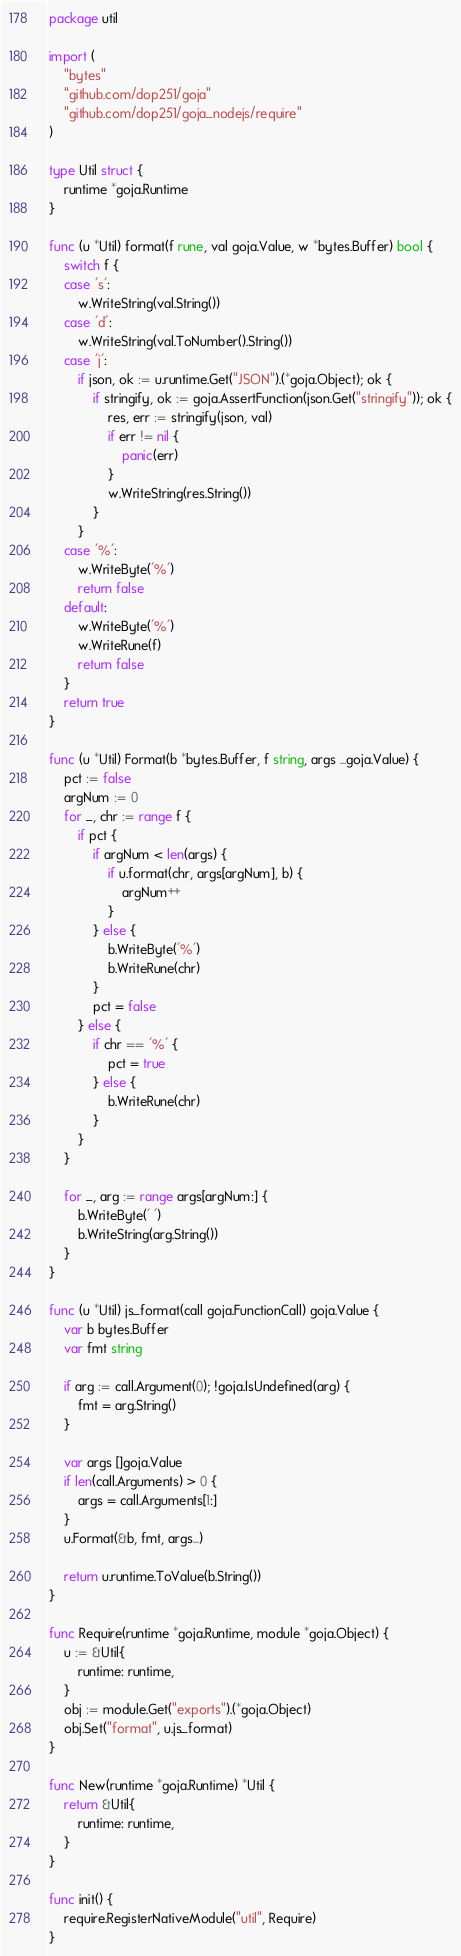<code> <loc_0><loc_0><loc_500><loc_500><_Go_>package util

import (
	"bytes"
	"github.com/dop251/goja"
	"github.com/dop251/goja_nodejs/require"
)

type Util struct {
	runtime *goja.Runtime
}

func (u *Util) format(f rune, val goja.Value, w *bytes.Buffer) bool {
	switch f {
	case 's':
		w.WriteString(val.String())
	case 'd':
		w.WriteString(val.ToNumber().String())
	case 'j':
		if json, ok := u.runtime.Get("JSON").(*goja.Object); ok {
			if stringify, ok := goja.AssertFunction(json.Get("stringify")); ok {
				res, err := stringify(json, val)
				if err != nil {
					panic(err)
				}
				w.WriteString(res.String())
			}
		}
	case '%':
		w.WriteByte('%')
		return false
	default:
		w.WriteByte('%')
		w.WriteRune(f)
		return false
	}
	return true
}

func (u *Util) Format(b *bytes.Buffer, f string, args ...goja.Value) {
	pct := false
	argNum := 0
	for _, chr := range f {
		if pct {
			if argNum < len(args) {
				if u.format(chr, args[argNum], b) {
					argNum++
				}
			} else {
				b.WriteByte('%')
				b.WriteRune(chr)
			}
			pct = false
		} else {
			if chr == '%' {
				pct = true
			} else {
				b.WriteRune(chr)
			}
		}
	}

	for _, arg := range args[argNum:] {
		b.WriteByte(' ')
		b.WriteString(arg.String())
	}
}

func (u *Util) js_format(call goja.FunctionCall) goja.Value {
	var b bytes.Buffer
	var fmt string

	if arg := call.Argument(0); !goja.IsUndefined(arg) {
		fmt = arg.String()
	}

	var args []goja.Value
	if len(call.Arguments) > 0 {
		args = call.Arguments[1:]
	}
	u.Format(&b, fmt, args...)

	return u.runtime.ToValue(b.String())
}

func Require(runtime *goja.Runtime, module *goja.Object) {
	u := &Util{
		runtime: runtime,
	}
	obj := module.Get("exports").(*goja.Object)
	obj.Set("format", u.js_format)
}

func New(runtime *goja.Runtime) *Util {
	return &Util{
		runtime: runtime,
	}
}

func init() {
	require.RegisterNativeModule("util", Require)
}
</code> 